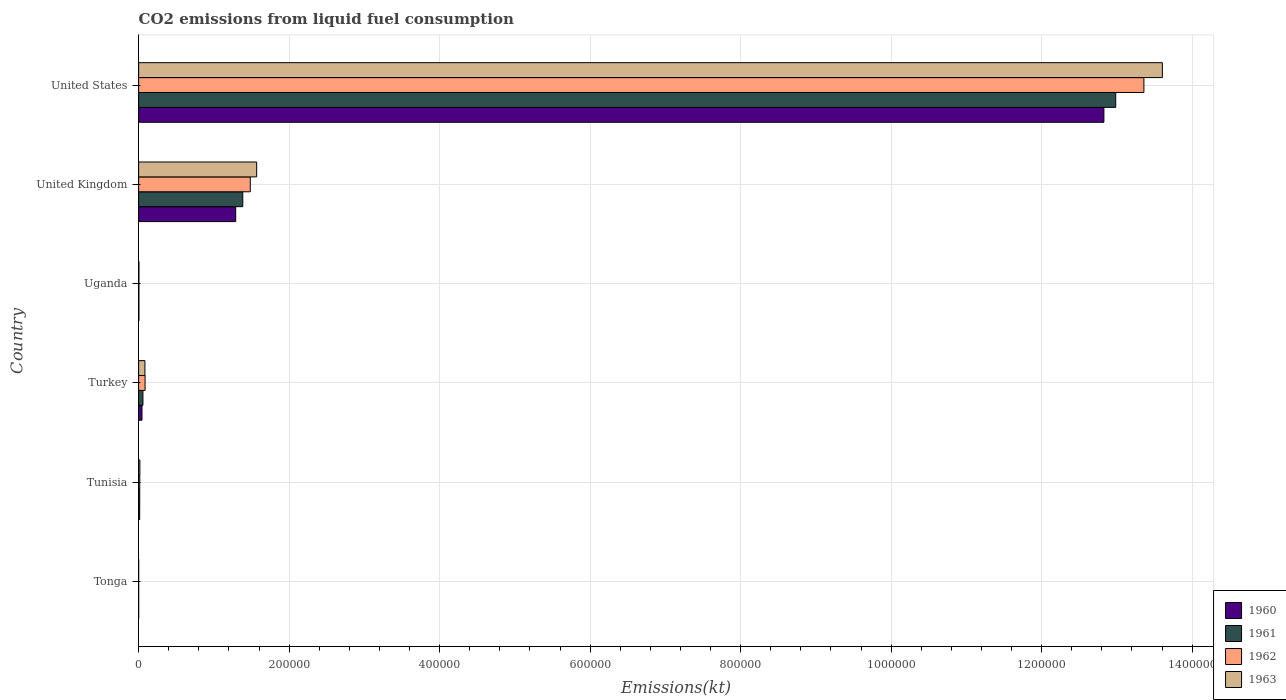How many groups of bars are there?
Keep it short and to the point. 6. Are the number of bars on each tick of the Y-axis equal?
Give a very brief answer. Yes. How many bars are there on the 5th tick from the top?
Your answer should be very brief. 4. How many bars are there on the 1st tick from the bottom?
Give a very brief answer. 4. What is the label of the 6th group of bars from the top?
Make the answer very short. Tonga. What is the amount of CO2 emitted in 1963 in Uganda?
Make the answer very short. 407.04. Across all countries, what is the maximum amount of CO2 emitted in 1961?
Provide a short and direct response. 1.30e+06. Across all countries, what is the minimum amount of CO2 emitted in 1962?
Make the answer very short. 11. In which country was the amount of CO2 emitted in 1962 maximum?
Provide a short and direct response. United States. In which country was the amount of CO2 emitted in 1960 minimum?
Your answer should be very brief. Tonga. What is the total amount of CO2 emitted in 1963 in the graph?
Provide a short and direct response. 1.53e+06. What is the difference between the amount of CO2 emitted in 1960 in Tonga and that in United Kingdom?
Ensure brevity in your answer.  -1.29e+05. What is the difference between the amount of CO2 emitted in 1962 in Turkey and the amount of CO2 emitted in 1963 in Tonga?
Give a very brief answer. 8555.11. What is the average amount of CO2 emitted in 1960 per country?
Your answer should be compact. 2.36e+05. What is the difference between the amount of CO2 emitted in 1961 and amount of CO2 emitted in 1960 in Uganda?
Offer a very short reply. -11. In how many countries, is the amount of CO2 emitted in 1960 greater than 680000 kt?
Keep it short and to the point. 1. What is the ratio of the amount of CO2 emitted in 1961 in Turkey to that in Uganda?
Offer a very short reply. 15.29. Is the amount of CO2 emitted in 1961 in Tonga less than that in United States?
Your response must be concise. Yes. Is the difference between the amount of CO2 emitted in 1961 in Tonga and Turkey greater than the difference between the amount of CO2 emitted in 1960 in Tonga and Turkey?
Keep it short and to the point. No. What is the difference between the highest and the second highest amount of CO2 emitted in 1963?
Make the answer very short. 1.20e+06. What is the difference between the highest and the lowest amount of CO2 emitted in 1960?
Provide a short and direct response. 1.28e+06. In how many countries, is the amount of CO2 emitted in 1961 greater than the average amount of CO2 emitted in 1961 taken over all countries?
Your answer should be very brief. 1. Is it the case that in every country, the sum of the amount of CO2 emitted in 1961 and amount of CO2 emitted in 1960 is greater than the sum of amount of CO2 emitted in 1962 and amount of CO2 emitted in 1963?
Offer a terse response. No. Is it the case that in every country, the sum of the amount of CO2 emitted in 1961 and amount of CO2 emitted in 1962 is greater than the amount of CO2 emitted in 1963?
Provide a short and direct response. Yes. What is the difference between two consecutive major ticks on the X-axis?
Your answer should be very brief. 2.00e+05. Are the values on the major ticks of X-axis written in scientific E-notation?
Provide a succinct answer. No. Does the graph contain any zero values?
Your answer should be very brief. No. What is the title of the graph?
Offer a very short reply. CO2 emissions from liquid fuel consumption. What is the label or title of the X-axis?
Provide a succinct answer. Emissions(kt). What is the Emissions(kt) of 1960 in Tonga?
Your answer should be compact. 11. What is the Emissions(kt) in 1961 in Tonga?
Your answer should be compact. 11. What is the Emissions(kt) of 1962 in Tonga?
Your answer should be compact. 11. What is the Emissions(kt) in 1963 in Tonga?
Provide a succinct answer. 11. What is the Emissions(kt) of 1960 in Tunisia?
Give a very brief answer. 1393.46. What is the Emissions(kt) in 1961 in Tunisia?
Give a very brief answer. 1452.13. What is the Emissions(kt) in 1962 in Tunisia?
Offer a very short reply. 1507.14. What is the Emissions(kt) in 1963 in Tunisia?
Keep it short and to the point. 1653.82. What is the Emissions(kt) of 1960 in Turkey?
Provide a succinct answer. 4473.74. What is the Emissions(kt) of 1961 in Turkey?
Provide a short and direct response. 5720.52. What is the Emissions(kt) in 1962 in Turkey?
Your response must be concise. 8566.11. What is the Emissions(kt) in 1963 in Turkey?
Keep it short and to the point. 8353.43. What is the Emissions(kt) in 1960 in Uganda?
Your response must be concise. 385.04. What is the Emissions(kt) in 1961 in Uganda?
Provide a succinct answer. 374.03. What is the Emissions(kt) in 1962 in Uganda?
Your response must be concise. 399.7. What is the Emissions(kt) in 1963 in Uganda?
Make the answer very short. 407.04. What is the Emissions(kt) in 1960 in United Kingdom?
Offer a very short reply. 1.29e+05. What is the Emissions(kt) of 1961 in United Kingdom?
Your response must be concise. 1.38e+05. What is the Emissions(kt) of 1962 in United Kingdom?
Make the answer very short. 1.48e+05. What is the Emissions(kt) in 1963 in United Kingdom?
Ensure brevity in your answer.  1.57e+05. What is the Emissions(kt) in 1960 in United States?
Provide a short and direct response. 1.28e+06. What is the Emissions(kt) in 1961 in United States?
Offer a terse response. 1.30e+06. What is the Emissions(kt) of 1962 in United States?
Ensure brevity in your answer.  1.34e+06. What is the Emissions(kt) in 1963 in United States?
Your answer should be compact. 1.36e+06. Across all countries, what is the maximum Emissions(kt) in 1960?
Make the answer very short. 1.28e+06. Across all countries, what is the maximum Emissions(kt) of 1961?
Your response must be concise. 1.30e+06. Across all countries, what is the maximum Emissions(kt) of 1962?
Provide a short and direct response. 1.34e+06. Across all countries, what is the maximum Emissions(kt) in 1963?
Your answer should be very brief. 1.36e+06. Across all countries, what is the minimum Emissions(kt) in 1960?
Keep it short and to the point. 11. Across all countries, what is the minimum Emissions(kt) in 1961?
Give a very brief answer. 11. Across all countries, what is the minimum Emissions(kt) of 1962?
Offer a very short reply. 11. Across all countries, what is the minimum Emissions(kt) of 1963?
Give a very brief answer. 11. What is the total Emissions(kt) in 1960 in the graph?
Provide a short and direct response. 1.42e+06. What is the total Emissions(kt) of 1961 in the graph?
Provide a short and direct response. 1.44e+06. What is the total Emissions(kt) in 1962 in the graph?
Ensure brevity in your answer.  1.49e+06. What is the total Emissions(kt) in 1963 in the graph?
Provide a succinct answer. 1.53e+06. What is the difference between the Emissions(kt) of 1960 in Tonga and that in Tunisia?
Provide a short and direct response. -1382.46. What is the difference between the Emissions(kt) of 1961 in Tonga and that in Tunisia?
Provide a succinct answer. -1441.13. What is the difference between the Emissions(kt) of 1962 in Tonga and that in Tunisia?
Give a very brief answer. -1496.14. What is the difference between the Emissions(kt) in 1963 in Tonga and that in Tunisia?
Ensure brevity in your answer.  -1642.82. What is the difference between the Emissions(kt) in 1960 in Tonga and that in Turkey?
Make the answer very short. -4462.74. What is the difference between the Emissions(kt) in 1961 in Tonga and that in Turkey?
Provide a succinct answer. -5709.52. What is the difference between the Emissions(kt) of 1962 in Tonga and that in Turkey?
Provide a short and direct response. -8555.11. What is the difference between the Emissions(kt) of 1963 in Tonga and that in Turkey?
Give a very brief answer. -8342.42. What is the difference between the Emissions(kt) of 1960 in Tonga and that in Uganda?
Offer a terse response. -374.03. What is the difference between the Emissions(kt) of 1961 in Tonga and that in Uganda?
Make the answer very short. -363.03. What is the difference between the Emissions(kt) in 1962 in Tonga and that in Uganda?
Make the answer very short. -388.7. What is the difference between the Emissions(kt) in 1963 in Tonga and that in Uganda?
Offer a very short reply. -396.04. What is the difference between the Emissions(kt) of 1960 in Tonga and that in United Kingdom?
Offer a terse response. -1.29e+05. What is the difference between the Emissions(kt) in 1961 in Tonga and that in United Kingdom?
Offer a very short reply. -1.38e+05. What is the difference between the Emissions(kt) in 1962 in Tonga and that in United Kingdom?
Provide a short and direct response. -1.48e+05. What is the difference between the Emissions(kt) in 1963 in Tonga and that in United Kingdom?
Your answer should be compact. -1.57e+05. What is the difference between the Emissions(kt) in 1960 in Tonga and that in United States?
Ensure brevity in your answer.  -1.28e+06. What is the difference between the Emissions(kt) in 1961 in Tonga and that in United States?
Keep it short and to the point. -1.30e+06. What is the difference between the Emissions(kt) in 1962 in Tonga and that in United States?
Provide a succinct answer. -1.34e+06. What is the difference between the Emissions(kt) of 1963 in Tonga and that in United States?
Make the answer very short. -1.36e+06. What is the difference between the Emissions(kt) in 1960 in Tunisia and that in Turkey?
Keep it short and to the point. -3080.28. What is the difference between the Emissions(kt) in 1961 in Tunisia and that in Turkey?
Provide a succinct answer. -4268.39. What is the difference between the Emissions(kt) of 1962 in Tunisia and that in Turkey?
Make the answer very short. -7058.98. What is the difference between the Emissions(kt) in 1963 in Tunisia and that in Turkey?
Your answer should be very brief. -6699.61. What is the difference between the Emissions(kt) of 1960 in Tunisia and that in Uganda?
Ensure brevity in your answer.  1008.42. What is the difference between the Emissions(kt) of 1961 in Tunisia and that in Uganda?
Offer a terse response. 1078.1. What is the difference between the Emissions(kt) of 1962 in Tunisia and that in Uganda?
Give a very brief answer. 1107.43. What is the difference between the Emissions(kt) in 1963 in Tunisia and that in Uganda?
Provide a short and direct response. 1246.78. What is the difference between the Emissions(kt) of 1960 in Tunisia and that in United Kingdom?
Your answer should be very brief. -1.28e+05. What is the difference between the Emissions(kt) in 1961 in Tunisia and that in United Kingdom?
Keep it short and to the point. -1.37e+05. What is the difference between the Emissions(kt) of 1962 in Tunisia and that in United Kingdom?
Make the answer very short. -1.47e+05. What is the difference between the Emissions(kt) of 1963 in Tunisia and that in United Kingdom?
Your answer should be compact. -1.55e+05. What is the difference between the Emissions(kt) in 1960 in Tunisia and that in United States?
Your response must be concise. -1.28e+06. What is the difference between the Emissions(kt) in 1961 in Tunisia and that in United States?
Your answer should be compact. -1.30e+06. What is the difference between the Emissions(kt) of 1962 in Tunisia and that in United States?
Make the answer very short. -1.33e+06. What is the difference between the Emissions(kt) of 1963 in Tunisia and that in United States?
Your response must be concise. -1.36e+06. What is the difference between the Emissions(kt) of 1960 in Turkey and that in Uganda?
Offer a very short reply. 4088.7. What is the difference between the Emissions(kt) in 1961 in Turkey and that in Uganda?
Your answer should be compact. 5346.49. What is the difference between the Emissions(kt) of 1962 in Turkey and that in Uganda?
Give a very brief answer. 8166.41. What is the difference between the Emissions(kt) of 1963 in Turkey and that in Uganda?
Ensure brevity in your answer.  7946.39. What is the difference between the Emissions(kt) in 1960 in Turkey and that in United Kingdom?
Keep it short and to the point. -1.25e+05. What is the difference between the Emissions(kt) of 1961 in Turkey and that in United Kingdom?
Provide a succinct answer. -1.33e+05. What is the difference between the Emissions(kt) in 1962 in Turkey and that in United Kingdom?
Your answer should be compact. -1.40e+05. What is the difference between the Emissions(kt) of 1963 in Turkey and that in United Kingdom?
Your answer should be very brief. -1.49e+05. What is the difference between the Emissions(kt) in 1960 in Turkey and that in United States?
Ensure brevity in your answer.  -1.28e+06. What is the difference between the Emissions(kt) of 1961 in Turkey and that in United States?
Provide a succinct answer. -1.29e+06. What is the difference between the Emissions(kt) of 1962 in Turkey and that in United States?
Provide a succinct answer. -1.33e+06. What is the difference between the Emissions(kt) of 1963 in Turkey and that in United States?
Provide a short and direct response. -1.35e+06. What is the difference between the Emissions(kt) in 1960 in Uganda and that in United Kingdom?
Your answer should be very brief. -1.29e+05. What is the difference between the Emissions(kt) in 1961 in Uganda and that in United Kingdom?
Provide a short and direct response. -1.38e+05. What is the difference between the Emissions(kt) in 1962 in Uganda and that in United Kingdom?
Provide a succinct answer. -1.48e+05. What is the difference between the Emissions(kt) in 1963 in Uganda and that in United Kingdom?
Offer a terse response. -1.56e+05. What is the difference between the Emissions(kt) of 1960 in Uganda and that in United States?
Your response must be concise. -1.28e+06. What is the difference between the Emissions(kt) of 1961 in Uganda and that in United States?
Provide a succinct answer. -1.30e+06. What is the difference between the Emissions(kt) of 1962 in Uganda and that in United States?
Your answer should be very brief. -1.34e+06. What is the difference between the Emissions(kt) in 1963 in Uganda and that in United States?
Give a very brief answer. -1.36e+06. What is the difference between the Emissions(kt) of 1960 in United Kingdom and that in United States?
Ensure brevity in your answer.  -1.15e+06. What is the difference between the Emissions(kt) in 1961 in United Kingdom and that in United States?
Provide a succinct answer. -1.16e+06. What is the difference between the Emissions(kt) of 1962 in United Kingdom and that in United States?
Your answer should be compact. -1.19e+06. What is the difference between the Emissions(kt) in 1963 in United Kingdom and that in United States?
Provide a short and direct response. -1.20e+06. What is the difference between the Emissions(kt) of 1960 in Tonga and the Emissions(kt) of 1961 in Tunisia?
Offer a very short reply. -1441.13. What is the difference between the Emissions(kt) of 1960 in Tonga and the Emissions(kt) of 1962 in Tunisia?
Your answer should be very brief. -1496.14. What is the difference between the Emissions(kt) of 1960 in Tonga and the Emissions(kt) of 1963 in Tunisia?
Make the answer very short. -1642.82. What is the difference between the Emissions(kt) in 1961 in Tonga and the Emissions(kt) in 1962 in Tunisia?
Your answer should be very brief. -1496.14. What is the difference between the Emissions(kt) of 1961 in Tonga and the Emissions(kt) of 1963 in Tunisia?
Provide a succinct answer. -1642.82. What is the difference between the Emissions(kt) in 1962 in Tonga and the Emissions(kt) in 1963 in Tunisia?
Provide a succinct answer. -1642.82. What is the difference between the Emissions(kt) of 1960 in Tonga and the Emissions(kt) of 1961 in Turkey?
Keep it short and to the point. -5709.52. What is the difference between the Emissions(kt) of 1960 in Tonga and the Emissions(kt) of 1962 in Turkey?
Your response must be concise. -8555.11. What is the difference between the Emissions(kt) of 1960 in Tonga and the Emissions(kt) of 1963 in Turkey?
Your answer should be compact. -8342.42. What is the difference between the Emissions(kt) of 1961 in Tonga and the Emissions(kt) of 1962 in Turkey?
Give a very brief answer. -8555.11. What is the difference between the Emissions(kt) in 1961 in Tonga and the Emissions(kt) in 1963 in Turkey?
Keep it short and to the point. -8342.42. What is the difference between the Emissions(kt) in 1962 in Tonga and the Emissions(kt) in 1963 in Turkey?
Provide a short and direct response. -8342.42. What is the difference between the Emissions(kt) of 1960 in Tonga and the Emissions(kt) of 1961 in Uganda?
Offer a very short reply. -363.03. What is the difference between the Emissions(kt) of 1960 in Tonga and the Emissions(kt) of 1962 in Uganda?
Give a very brief answer. -388.7. What is the difference between the Emissions(kt) in 1960 in Tonga and the Emissions(kt) in 1963 in Uganda?
Provide a succinct answer. -396.04. What is the difference between the Emissions(kt) of 1961 in Tonga and the Emissions(kt) of 1962 in Uganda?
Offer a terse response. -388.7. What is the difference between the Emissions(kt) of 1961 in Tonga and the Emissions(kt) of 1963 in Uganda?
Offer a terse response. -396.04. What is the difference between the Emissions(kt) in 1962 in Tonga and the Emissions(kt) in 1963 in Uganda?
Keep it short and to the point. -396.04. What is the difference between the Emissions(kt) of 1960 in Tonga and the Emissions(kt) of 1961 in United Kingdom?
Provide a short and direct response. -1.38e+05. What is the difference between the Emissions(kt) in 1960 in Tonga and the Emissions(kt) in 1962 in United Kingdom?
Your response must be concise. -1.48e+05. What is the difference between the Emissions(kt) in 1960 in Tonga and the Emissions(kt) in 1963 in United Kingdom?
Your answer should be compact. -1.57e+05. What is the difference between the Emissions(kt) in 1961 in Tonga and the Emissions(kt) in 1962 in United Kingdom?
Provide a short and direct response. -1.48e+05. What is the difference between the Emissions(kt) in 1961 in Tonga and the Emissions(kt) in 1963 in United Kingdom?
Your answer should be very brief. -1.57e+05. What is the difference between the Emissions(kt) of 1962 in Tonga and the Emissions(kt) of 1963 in United Kingdom?
Provide a succinct answer. -1.57e+05. What is the difference between the Emissions(kt) of 1960 in Tonga and the Emissions(kt) of 1961 in United States?
Your response must be concise. -1.30e+06. What is the difference between the Emissions(kt) of 1960 in Tonga and the Emissions(kt) of 1962 in United States?
Your answer should be compact. -1.34e+06. What is the difference between the Emissions(kt) in 1960 in Tonga and the Emissions(kt) in 1963 in United States?
Keep it short and to the point. -1.36e+06. What is the difference between the Emissions(kt) in 1961 in Tonga and the Emissions(kt) in 1962 in United States?
Make the answer very short. -1.34e+06. What is the difference between the Emissions(kt) of 1961 in Tonga and the Emissions(kt) of 1963 in United States?
Your answer should be very brief. -1.36e+06. What is the difference between the Emissions(kt) in 1962 in Tonga and the Emissions(kt) in 1963 in United States?
Keep it short and to the point. -1.36e+06. What is the difference between the Emissions(kt) of 1960 in Tunisia and the Emissions(kt) of 1961 in Turkey?
Make the answer very short. -4327.06. What is the difference between the Emissions(kt) of 1960 in Tunisia and the Emissions(kt) of 1962 in Turkey?
Ensure brevity in your answer.  -7172.65. What is the difference between the Emissions(kt) of 1960 in Tunisia and the Emissions(kt) of 1963 in Turkey?
Provide a short and direct response. -6959.97. What is the difference between the Emissions(kt) in 1961 in Tunisia and the Emissions(kt) in 1962 in Turkey?
Provide a succinct answer. -7113.98. What is the difference between the Emissions(kt) of 1961 in Tunisia and the Emissions(kt) of 1963 in Turkey?
Offer a very short reply. -6901.29. What is the difference between the Emissions(kt) in 1962 in Tunisia and the Emissions(kt) in 1963 in Turkey?
Give a very brief answer. -6846.29. What is the difference between the Emissions(kt) of 1960 in Tunisia and the Emissions(kt) of 1961 in Uganda?
Provide a succinct answer. 1019.43. What is the difference between the Emissions(kt) of 1960 in Tunisia and the Emissions(kt) of 1962 in Uganda?
Give a very brief answer. 993.76. What is the difference between the Emissions(kt) in 1960 in Tunisia and the Emissions(kt) in 1963 in Uganda?
Provide a succinct answer. 986.42. What is the difference between the Emissions(kt) of 1961 in Tunisia and the Emissions(kt) of 1962 in Uganda?
Keep it short and to the point. 1052.43. What is the difference between the Emissions(kt) of 1961 in Tunisia and the Emissions(kt) of 1963 in Uganda?
Make the answer very short. 1045.1. What is the difference between the Emissions(kt) of 1962 in Tunisia and the Emissions(kt) of 1963 in Uganda?
Provide a short and direct response. 1100.1. What is the difference between the Emissions(kt) in 1960 in Tunisia and the Emissions(kt) in 1961 in United Kingdom?
Keep it short and to the point. -1.37e+05. What is the difference between the Emissions(kt) in 1960 in Tunisia and the Emissions(kt) in 1962 in United Kingdom?
Your answer should be very brief. -1.47e+05. What is the difference between the Emissions(kt) of 1960 in Tunisia and the Emissions(kt) of 1963 in United Kingdom?
Make the answer very short. -1.55e+05. What is the difference between the Emissions(kt) of 1961 in Tunisia and the Emissions(kt) of 1962 in United Kingdom?
Your answer should be compact. -1.47e+05. What is the difference between the Emissions(kt) of 1961 in Tunisia and the Emissions(kt) of 1963 in United Kingdom?
Offer a terse response. -1.55e+05. What is the difference between the Emissions(kt) in 1962 in Tunisia and the Emissions(kt) in 1963 in United Kingdom?
Your response must be concise. -1.55e+05. What is the difference between the Emissions(kt) in 1960 in Tunisia and the Emissions(kt) in 1961 in United States?
Your response must be concise. -1.30e+06. What is the difference between the Emissions(kt) of 1960 in Tunisia and the Emissions(kt) of 1962 in United States?
Make the answer very short. -1.33e+06. What is the difference between the Emissions(kt) in 1960 in Tunisia and the Emissions(kt) in 1963 in United States?
Your answer should be compact. -1.36e+06. What is the difference between the Emissions(kt) of 1961 in Tunisia and the Emissions(kt) of 1962 in United States?
Provide a succinct answer. -1.33e+06. What is the difference between the Emissions(kt) of 1961 in Tunisia and the Emissions(kt) of 1963 in United States?
Make the answer very short. -1.36e+06. What is the difference between the Emissions(kt) of 1962 in Tunisia and the Emissions(kt) of 1963 in United States?
Provide a short and direct response. -1.36e+06. What is the difference between the Emissions(kt) in 1960 in Turkey and the Emissions(kt) in 1961 in Uganda?
Ensure brevity in your answer.  4099.71. What is the difference between the Emissions(kt) in 1960 in Turkey and the Emissions(kt) in 1962 in Uganda?
Your answer should be very brief. 4074.04. What is the difference between the Emissions(kt) of 1960 in Turkey and the Emissions(kt) of 1963 in Uganda?
Offer a terse response. 4066.7. What is the difference between the Emissions(kt) in 1961 in Turkey and the Emissions(kt) in 1962 in Uganda?
Offer a terse response. 5320.82. What is the difference between the Emissions(kt) of 1961 in Turkey and the Emissions(kt) of 1963 in Uganda?
Give a very brief answer. 5313.48. What is the difference between the Emissions(kt) of 1962 in Turkey and the Emissions(kt) of 1963 in Uganda?
Provide a succinct answer. 8159.07. What is the difference between the Emissions(kt) in 1960 in Turkey and the Emissions(kt) in 1961 in United Kingdom?
Your response must be concise. -1.34e+05. What is the difference between the Emissions(kt) of 1960 in Turkey and the Emissions(kt) of 1962 in United Kingdom?
Your answer should be compact. -1.44e+05. What is the difference between the Emissions(kt) in 1960 in Turkey and the Emissions(kt) in 1963 in United Kingdom?
Offer a very short reply. -1.52e+05. What is the difference between the Emissions(kt) in 1961 in Turkey and the Emissions(kt) in 1962 in United Kingdom?
Ensure brevity in your answer.  -1.43e+05. What is the difference between the Emissions(kt) of 1961 in Turkey and the Emissions(kt) of 1963 in United Kingdom?
Provide a succinct answer. -1.51e+05. What is the difference between the Emissions(kt) in 1962 in Turkey and the Emissions(kt) in 1963 in United Kingdom?
Keep it short and to the point. -1.48e+05. What is the difference between the Emissions(kt) of 1960 in Turkey and the Emissions(kt) of 1961 in United States?
Give a very brief answer. -1.29e+06. What is the difference between the Emissions(kt) in 1960 in Turkey and the Emissions(kt) in 1962 in United States?
Your answer should be very brief. -1.33e+06. What is the difference between the Emissions(kt) of 1960 in Turkey and the Emissions(kt) of 1963 in United States?
Your answer should be very brief. -1.36e+06. What is the difference between the Emissions(kt) in 1961 in Turkey and the Emissions(kt) in 1962 in United States?
Offer a terse response. -1.33e+06. What is the difference between the Emissions(kt) in 1961 in Turkey and the Emissions(kt) in 1963 in United States?
Make the answer very short. -1.35e+06. What is the difference between the Emissions(kt) of 1962 in Turkey and the Emissions(kt) of 1963 in United States?
Keep it short and to the point. -1.35e+06. What is the difference between the Emissions(kt) in 1960 in Uganda and the Emissions(kt) in 1961 in United Kingdom?
Keep it short and to the point. -1.38e+05. What is the difference between the Emissions(kt) of 1960 in Uganda and the Emissions(kt) of 1962 in United Kingdom?
Make the answer very short. -1.48e+05. What is the difference between the Emissions(kt) of 1960 in Uganda and the Emissions(kt) of 1963 in United Kingdom?
Make the answer very short. -1.56e+05. What is the difference between the Emissions(kt) of 1961 in Uganda and the Emissions(kt) of 1962 in United Kingdom?
Give a very brief answer. -1.48e+05. What is the difference between the Emissions(kt) of 1961 in Uganda and the Emissions(kt) of 1963 in United Kingdom?
Give a very brief answer. -1.56e+05. What is the difference between the Emissions(kt) in 1962 in Uganda and the Emissions(kt) in 1963 in United Kingdom?
Ensure brevity in your answer.  -1.56e+05. What is the difference between the Emissions(kt) of 1960 in Uganda and the Emissions(kt) of 1961 in United States?
Your response must be concise. -1.30e+06. What is the difference between the Emissions(kt) in 1960 in Uganda and the Emissions(kt) in 1962 in United States?
Your answer should be very brief. -1.34e+06. What is the difference between the Emissions(kt) of 1960 in Uganda and the Emissions(kt) of 1963 in United States?
Your answer should be very brief. -1.36e+06. What is the difference between the Emissions(kt) of 1961 in Uganda and the Emissions(kt) of 1962 in United States?
Provide a succinct answer. -1.34e+06. What is the difference between the Emissions(kt) of 1961 in Uganda and the Emissions(kt) of 1963 in United States?
Ensure brevity in your answer.  -1.36e+06. What is the difference between the Emissions(kt) of 1962 in Uganda and the Emissions(kt) of 1963 in United States?
Offer a terse response. -1.36e+06. What is the difference between the Emissions(kt) in 1960 in United Kingdom and the Emissions(kt) in 1961 in United States?
Provide a succinct answer. -1.17e+06. What is the difference between the Emissions(kt) in 1960 in United Kingdom and the Emissions(kt) in 1962 in United States?
Provide a short and direct response. -1.21e+06. What is the difference between the Emissions(kt) in 1960 in United Kingdom and the Emissions(kt) in 1963 in United States?
Your answer should be compact. -1.23e+06. What is the difference between the Emissions(kt) of 1961 in United Kingdom and the Emissions(kt) of 1962 in United States?
Give a very brief answer. -1.20e+06. What is the difference between the Emissions(kt) of 1961 in United Kingdom and the Emissions(kt) of 1963 in United States?
Provide a short and direct response. -1.22e+06. What is the difference between the Emissions(kt) in 1962 in United Kingdom and the Emissions(kt) in 1963 in United States?
Give a very brief answer. -1.21e+06. What is the average Emissions(kt) in 1960 per country?
Make the answer very short. 2.36e+05. What is the average Emissions(kt) of 1961 per country?
Your answer should be compact. 2.41e+05. What is the average Emissions(kt) of 1962 per country?
Ensure brevity in your answer.  2.49e+05. What is the average Emissions(kt) in 1963 per country?
Your response must be concise. 2.55e+05. What is the difference between the Emissions(kt) in 1960 and Emissions(kt) in 1961 in Tonga?
Your response must be concise. 0. What is the difference between the Emissions(kt) of 1960 and Emissions(kt) of 1963 in Tonga?
Give a very brief answer. 0. What is the difference between the Emissions(kt) in 1961 and Emissions(kt) in 1962 in Tonga?
Your answer should be compact. 0. What is the difference between the Emissions(kt) of 1960 and Emissions(kt) of 1961 in Tunisia?
Provide a short and direct response. -58.67. What is the difference between the Emissions(kt) in 1960 and Emissions(kt) in 1962 in Tunisia?
Make the answer very short. -113.68. What is the difference between the Emissions(kt) of 1960 and Emissions(kt) of 1963 in Tunisia?
Offer a very short reply. -260.36. What is the difference between the Emissions(kt) of 1961 and Emissions(kt) of 1962 in Tunisia?
Your response must be concise. -55.01. What is the difference between the Emissions(kt) in 1961 and Emissions(kt) in 1963 in Tunisia?
Offer a terse response. -201.69. What is the difference between the Emissions(kt) in 1962 and Emissions(kt) in 1963 in Tunisia?
Give a very brief answer. -146.68. What is the difference between the Emissions(kt) of 1960 and Emissions(kt) of 1961 in Turkey?
Offer a very short reply. -1246.78. What is the difference between the Emissions(kt) in 1960 and Emissions(kt) in 1962 in Turkey?
Provide a succinct answer. -4092.37. What is the difference between the Emissions(kt) of 1960 and Emissions(kt) of 1963 in Turkey?
Your answer should be compact. -3879.69. What is the difference between the Emissions(kt) of 1961 and Emissions(kt) of 1962 in Turkey?
Provide a short and direct response. -2845.59. What is the difference between the Emissions(kt) of 1961 and Emissions(kt) of 1963 in Turkey?
Your response must be concise. -2632.91. What is the difference between the Emissions(kt) of 1962 and Emissions(kt) of 1963 in Turkey?
Keep it short and to the point. 212.69. What is the difference between the Emissions(kt) in 1960 and Emissions(kt) in 1961 in Uganda?
Make the answer very short. 11. What is the difference between the Emissions(kt) in 1960 and Emissions(kt) in 1962 in Uganda?
Provide a succinct answer. -14.67. What is the difference between the Emissions(kt) in 1960 and Emissions(kt) in 1963 in Uganda?
Offer a terse response. -22. What is the difference between the Emissions(kt) of 1961 and Emissions(kt) of 1962 in Uganda?
Give a very brief answer. -25.67. What is the difference between the Emissions(kt) of 1961 and Emissions(kt) of 1963 in Uganda?
Your answer should be very brief. -33. What is the difference between the Emissions(kt) of 1962 and Emissions(kt) of 1963 in Uganda?
Your answer should be compact. -7.33. What is the difference between the Emissions(kt) in 1960 and Emissions(kt) in 1961 in United Kingdom?
Your answer should be very brief. -9380.19. What is the difference between the Emissions(kt) in 1960 and Emissions(kt) in 1962 in United Kingdom?
Keep it short and to the point. -1.94e+04. What is the difference between the Emissions(kt) in 1960 and Emissions(kt) in 1963 in United Kingdom?
Ensure brevity in your answer.  -2.79e+04. What is the difference between the Emissions(kt) in 1961 and Emissions(kt) in 1962 in United Kingdom?
Give a very brief answer. -9992.58. What is the difference between the Emissions(kt) of 1961 and Emissions(kt) of 1963 in United Kingdom?
Your answer should be very brief. -1.85e+04. What is the difference between the Emissions(kt) of 1962 and Emissions(kt) of 1963 in United Kingdom?
Make the answer very short. -8489.1. What is the difference between the Emissions(kt) in 1960 and Emissions(kt) in 1961 in United States?
Make the answer very short. -1.57e+04. What is the difference between the Emissions(kt) in 1960 and Emissions(kt) in 1962 in United States?
Ensure brevity in your answer.  -5.32e+04. What is the difference between the Emissions(kt) of 1960 and Emissions(kt) of 1963 in United States?
Make the answer very short. -7.77e+04. What is the difference between the Emissions(kt) of 1961 and Emissions(kt) of 1962 in United States?
Ensure brevity in your answer.  -3.75e+04. What is the difference between the Emissions(kt) of 1961 and Emissions(kt) of 1963 in United States?
Make the answer very short. -6.20e+04. What is the difference between the Emissions(kt) in 1962 and Emissions(kt) in 1963 in United States?
Offer a terse response. -2.45e+04. What is the ratio of the Emissions(kt) of 1960 in Tonga to that in Tunisia?
Make the answer very short. 0.01. What is the ratio of the Emissions(kt) of 1961 in Tonga to that in Tunisia?
Your response must be concise. 0.01. What is the ratio of the Emissions(kt) in 1962 in Tonga to that in Tunisia?
Offer a terse response. 0.01. What is the ratio of the Emissions(kt) of 1963 in Tonga to that in Tunisia?
Make the answer very short. 0.01. What is the ratio of the Emissions(kt) in 1960 in Tonga to that in Turkey?
Ensure brevity in your answer.  0. What is the ratio of the Emissions(kt) in 1961 in Tonga to that in Turkey?
Offer a very short reply. 0. What is the ratio of the Emissions(kt) in 1962 in Tonga to that in Turkey?
Your response must be concise. 0. What is the ratio of the Emissions(kt) of 1963 in Tonga to that in Turkey?
Your answer should be very brief. 0. What is the ratio of the Emissions(kt) in 1960 in Tonga to that in Uganda?
Provide a short and direct response. 0.03. What is the ratio of the Emissions(kt) in 1961 in Tonga to that in Uganda?
Provide a succinct answer. 0.03. What is the ratio of the Emissions(kt) of 1962 in Tonga to that in Uganda?
Offer a very short reply. 0.03. What is the ratio of the Emissions(kt) in 1963 in Tonga to that in Uganda?
Offer a very short reply. 0.03. What is the ratio of the Emissions(kt) in 1960 in Tonga to that in United Kingdom?
Offer a very short reply. 0. What is the ratio of the Emissions(kt) of 1961 in Tonga to that in United Kingdom?
Ensure brevity in your answer.  0. What is the ratio of the Emissions(kt) of 1963 in Tonga to that in United Kingdom?
Give a very brief answer. 0. What is the ratio of the Emissions(kt) of 1960 in Tonga to that in United States?
Make the answer very short. 0. What is the ratio of the Emissions(kt) of 1961 in Tonga to that in United States?
Provide a succinct answer. 0. What is the ratio of the Emissions(kt) of 1960 in Tunisia to that in Turkey?
Keep it short and to the point. 0.31. What is the ratio of the Emissions(kt) in 1961 in Tunisia to that in Turkey?
Ensure brevity in your answer.  0.25. What is the ratio of the Emissions(kt) of 1962 in Tunisia to that in Turkey?
Provide a succinct answer. 0.18. What is the ratio of the Emissions(kt) in 1963 in Tunisia to that in Turkey?
Offer a terse response. 0.2. What is the ratio of the Emissions(kt) of 1960 in Tunisia to that in Uganda?
Give a very brief answer. 3.62. What is the ratio of the Emissions(kt) in 1961 in Tunisia to that in Uganda?
Offer a terse response. 3.88. What is the ratio of the Emissions(kt) of 1962 in Tunisia to that in Uganda?
Offer a terse response. 3.77. What is the ratio of the Emissions(kt) of 1963 in Tunisia to that in Uganda?
Keep it short and to the point. 4.06. What is the ratio of the Emissions(kt) in 1960 in Tunisia to that in United Kingdom?
Ensure brevity in your answer.  0.01. What is the ratio of the Emissions(kt) of 1961 in Tunisia to that in United Kingdom?
Your answer should be very brief. 0.01. What is the ratio of the Emissions(kt) in 1962 in Tunisia to that in United Kingdom?
Provide a succinct answer. 0.01. What is the ratio of the Emissions(kt) of 1963 in Tunisia to that in United Kingdom?
Your answer should be compact. 0.01. What is the ratio of the Emissions(kt) in 1960 in Tunisia to that in United States?
Provide a short and direct response. 0. What is the ratio of the Emissions(kt) of 1961 in Tunisia to that in United States?
Offer a terse response. 0. What is the ratio of the Emissions(kt) in 1962 in Tunisia to that in United States?
Provide a short and direct response. 0. What is the ratio of the Emissions(kt) of 1963 in Tunisia to that in United States?
Give a very brief answer. 0. What is the ratio of the Emissions(kt) of 1960 in Turkey to that in Uganda?
Your response must be concise. 11.62. What is the ratio of the Emissions(kt) in 1961 in Turkey to that in Uganda?
Ensure brevity in your answer.  15.29. What is the ratio of the Emissions(kt) in 1962 in Turkey to that in Uganda?
Keep it short and to the point. 21.43. What is the ratio of the Emissions(kt) in 1963 in Turkey to that in Uganda?
Make the answer very short. 20.52. What is the ratio of the Emissions(kt) of 1960 in Turkey to that in United Kingdom?
Ensure brevity in your answer.  0.03. What is the ratio of the Emissions(kt) of 1961 in Turkey to that in United Kingdom?
Your answer should be very brief. 0.04. What is the ratio of the Emissions(kt) in 1962 in Turkey to that in United Kingdom?
Your answer should be compact. 0.06. What is the ratio of the Emissions(kt) of 1963 in Turkey to that in United Kingdom?
Keep it short and to the point. 0.05. What is the ratio of the Emissions(kt) in 1960 in Turkey to that in United States?
Offer a terse response. 0. What is the ratio of the Emissions(kt) in 1961 in Turkey to that in United States?
Provide a short and direct response. 0. What is the ratio of the Emissions(kt) in 1962 in Turkey to that in United States?
Keep it short and to the point. 0.01. What is the ratio of the Emissions(kt) of 1963 in Turkey to that in United States?
Your answer should be compact. 0.01. What is the ratio of the Emissions(kt) of 1960 in Uganda to that in United Kingdom?
Your answer should be very brief. 0. What is the ratio of the Emissions(kt) of 1961 in Uganda to that in United Kingdom?
Make the answer very short. 0. What is the ratio of the Emissions(kt) in 1962 in Uganda to that in United Kingdom?
Keep it short and to the point. 0. What is the ratio of the Emissions(kt) in 1963 in Uganda to that in United Kingdom?
Provide a succinct answer. 0. What is the ratio of the Emissions(kt) of 1961 in Uganda to that in United States?
Ensure brevity in your answer.  0. What is the ratio of the Emissions(kt) of 1960 in United Kingdom to that in United States?
Give a very brief answer. 0.1. What is the ratio of the Emissions(kt) of 1961 in United Kingdom to that in United States?
Offer a very short reply. 0.11. What is the ratio of the Emissions(kt) in 1963 in United Kingdom to that in United States?
Provide a short and direct response. 0.12. What is the difference between the highest and the second highest Emissions(kt) of 1960?
Make the answer very short. 1.15e+06. What is the difference between the highest and the second highest Emissions(kt) in 1961?
Offer a very short reply. 1.16e+06. What is the difference between the highest and the second highest Emissions(kt) in 1962?
Offer a terse response. 1.19e+06. What is the difference between the highest and the second highest Emissions(kt) of 1963?
Your answer should be compact. 1.20e+06. What is the difference between the highest and the lowest Emissions(kt) in 1960?
Your response must be concise. 1.28e+06. What is the difference between the highest and the lowest Emissions(kt) of 1961?
Offer a very short reply. 1.30e+06. What is the difference between the highest and the lowest Emissions(kt) of 1962?
Give a very brief answer. 1.34e+06. What is the difference between the highest and the lowest Emissions(kt) of 1963?
Ensure brevity in your answer.  1.36e+06. 